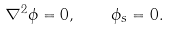<formula> <loc_0><loc_0><loc_500><loc_500>\nabla ^ { 2 } \phi = 0 , \quad \phi _ { s } = 0 .</formula> 